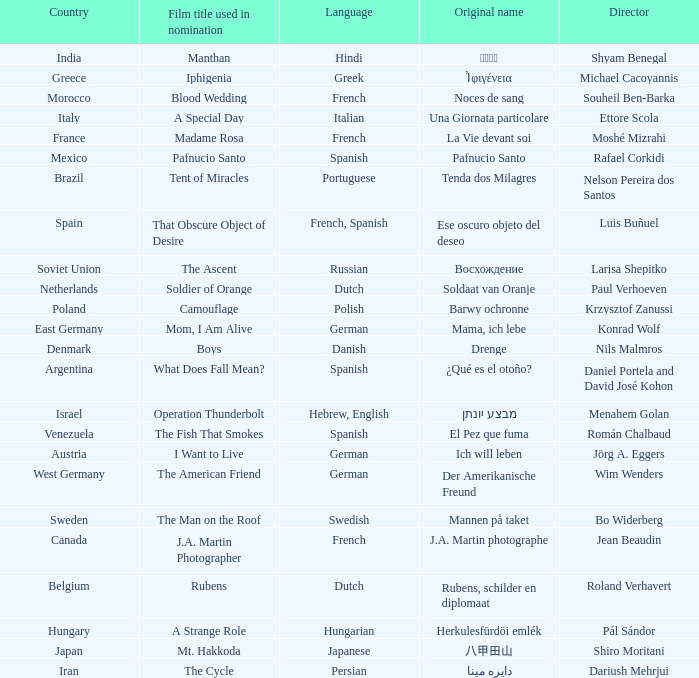Which director is from Italy? Ettore Scola. 